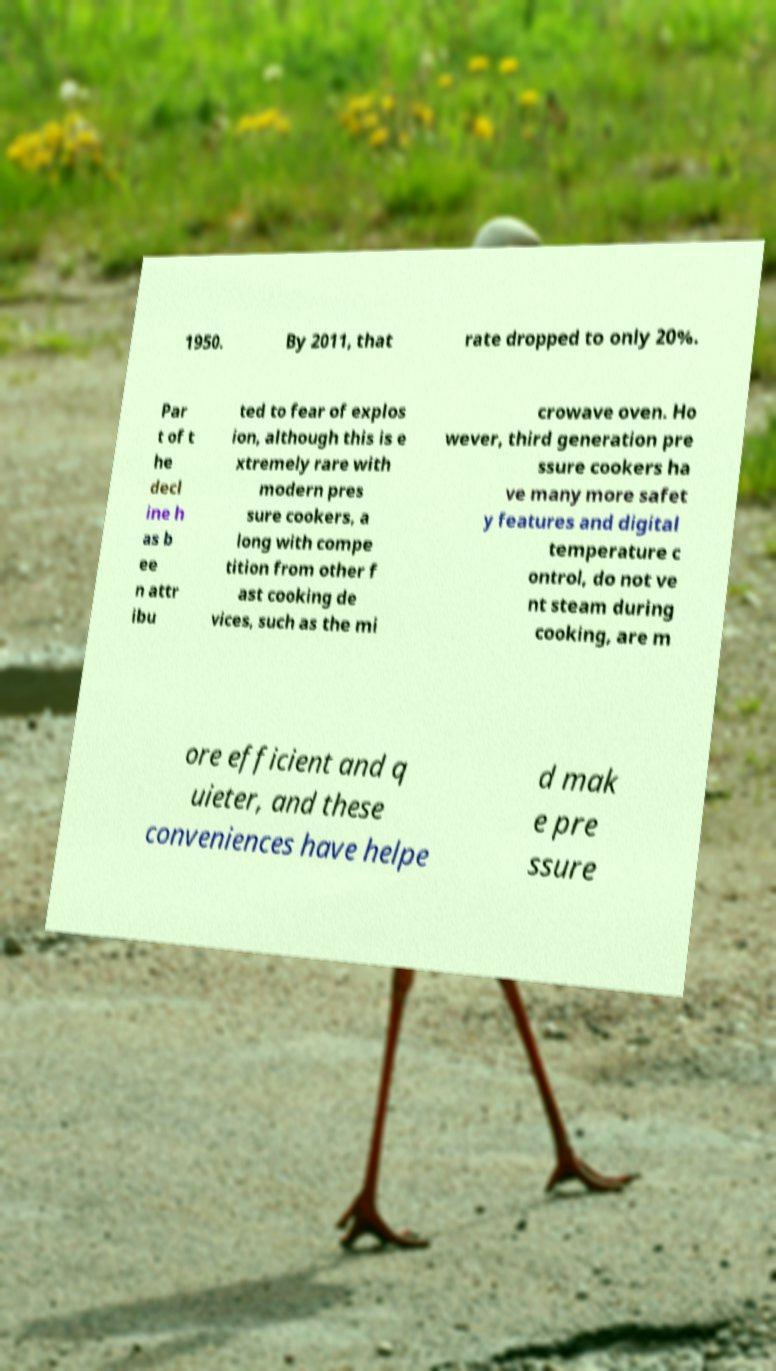What messages or text are displayed in this image? I need them in a readable, typed format. 1950. By 2011, that rate dropped to only 20%. Par t of t he decl ine h as b ee n attr ibu ted to fear of explos ion, although this is e xtremely rare with modern pres sure cookers, a long with compe tition from other f ast cooking de vices, such as the mi crowave oven. Ho wever, third generation pre ssure cookers ha ve many more safet y features and digital temperature c ontrol, do not ve nt steam during cooking, are m ore efficient and q uieter, and these conveniences have helpe d mak e pre ssure 